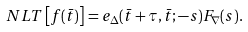<formula> <loc_0><loc_0><loc_500><loc_500>N L T \left [ f ( \bar { t } ) \right ] = e _ { \Delta } ( \bar { t } + \tau , \bar { t } ; - s ) F _ { \nabla } ( s ) .</formula> 